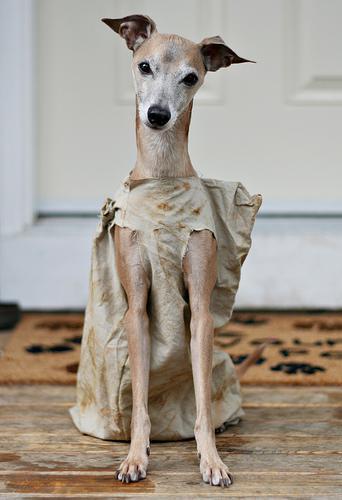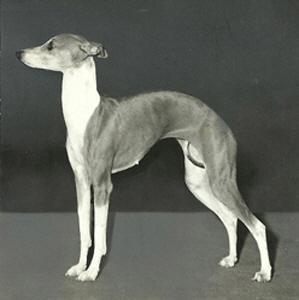The first image is the image on the left, the second image is the image on the right. Assess this claim about the two images: "One image contains five dogs.". Correct or not? Answer yes or no. No. The first image is the image on the left, the second image is the image on the right. Given the left and right images, does the statement "there are only two canines in the image on the right side" hold true? Answer yes or no. No. 